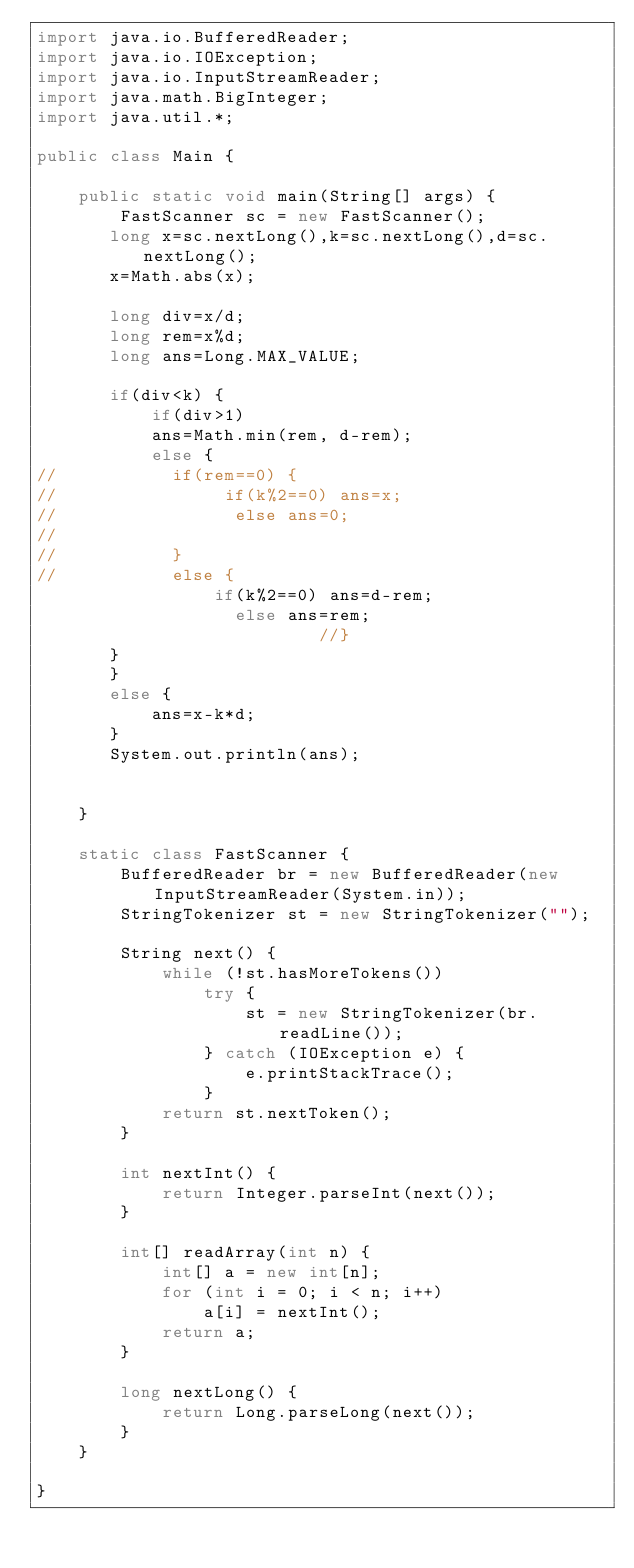<code> <loc_0><loc_0><loc_500><loc_500><_Java_>import java.io.BufferedReader;
import java.io.IOException;
import java.io.InputStreamReader;
import java.math.BigInteger;
import java.util.*;

public class Main {

	public static void main(String[] args) {
		FastScanner sc = new FastScanner();
       long x=sc.nextLong(),k=sc.nextLong(),d=sc.nextLong();
       x=Math.abs(x);
       
       long div=x/d;
       long rem=x%d;
       long ans=Long.MAX_VALUE;
       
       if(div<k) {
    	   if(div>1)
    	   ans=Math.min(rem, d-rem);
    	   else {
//    		 if(rem==0) {
//    			  if(k%2==0) ans=x;
//       		   else ans=0;
//       		   
//    		 }
//    		 else {
    			 if(k%2==0) ans=d-rem;
         		   else ans=rem;
         		       	   //}
       }
       }
       else {
    	   ans=x-k*d;
       }
       System.out.println(ans);
         
       
	}

	static class FastScanner {
		BufferedReader br = new BufferedReader(new InputStreamReader(System.in));
		StringTokenizer st = new StringTokenizer("");

		String next() {
			while (!st.hasMoreTokens())
				try {
					st = new StringTokenizer(br.readLine());
				} catch (IOException e) {
					e.printStackTrace();
				}
			return st.nextToken();
		}

		int nextInt() {
			return Integer.parseInt(next());
		}

		int[] readArray(int n) {
			int[] a = new int[n];
			for (int i = 0; i < n; i++)
				a[i] = nextInt();
			return a;
		}

		long nextLong() {
			return Long.parseLong(next());
		}
	}

}</code> 